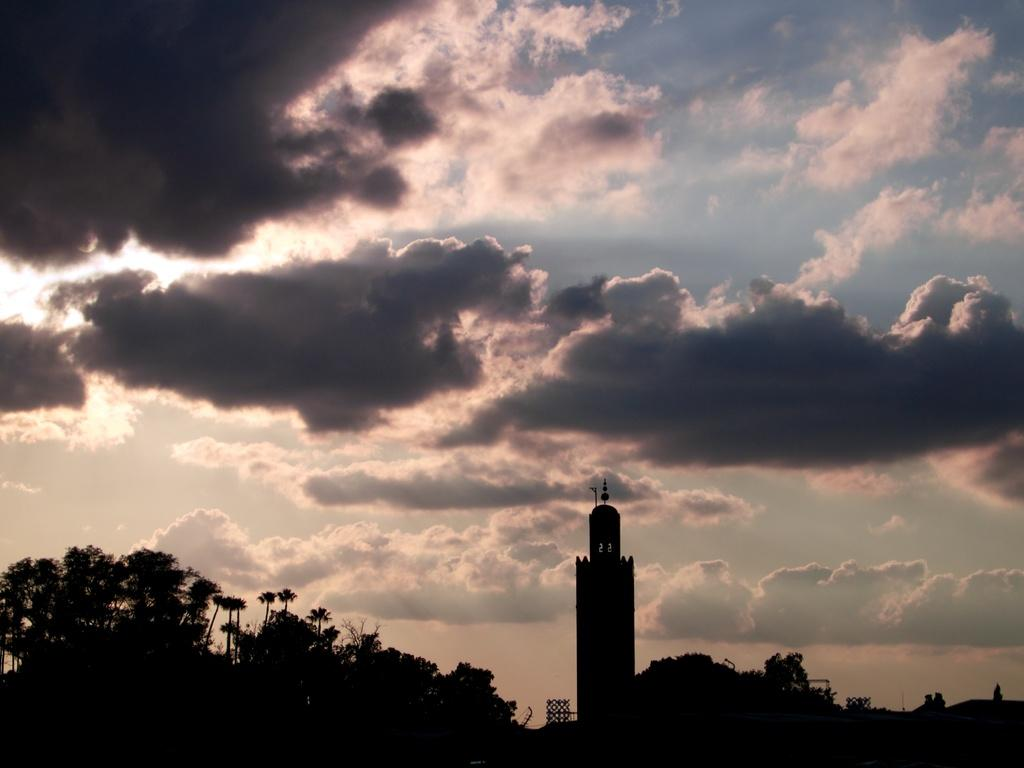What type of natural elements can be seen in the image? There are trees in the image. What type of man-made structures are present in the image? There are buildings in the image. What is visible in the sky in the image? There are clouds visible in the image. What type of hairstyle can be seen on the trees in the image? There are no hairstyles present on the trees in the image, as trees do not have hair. 